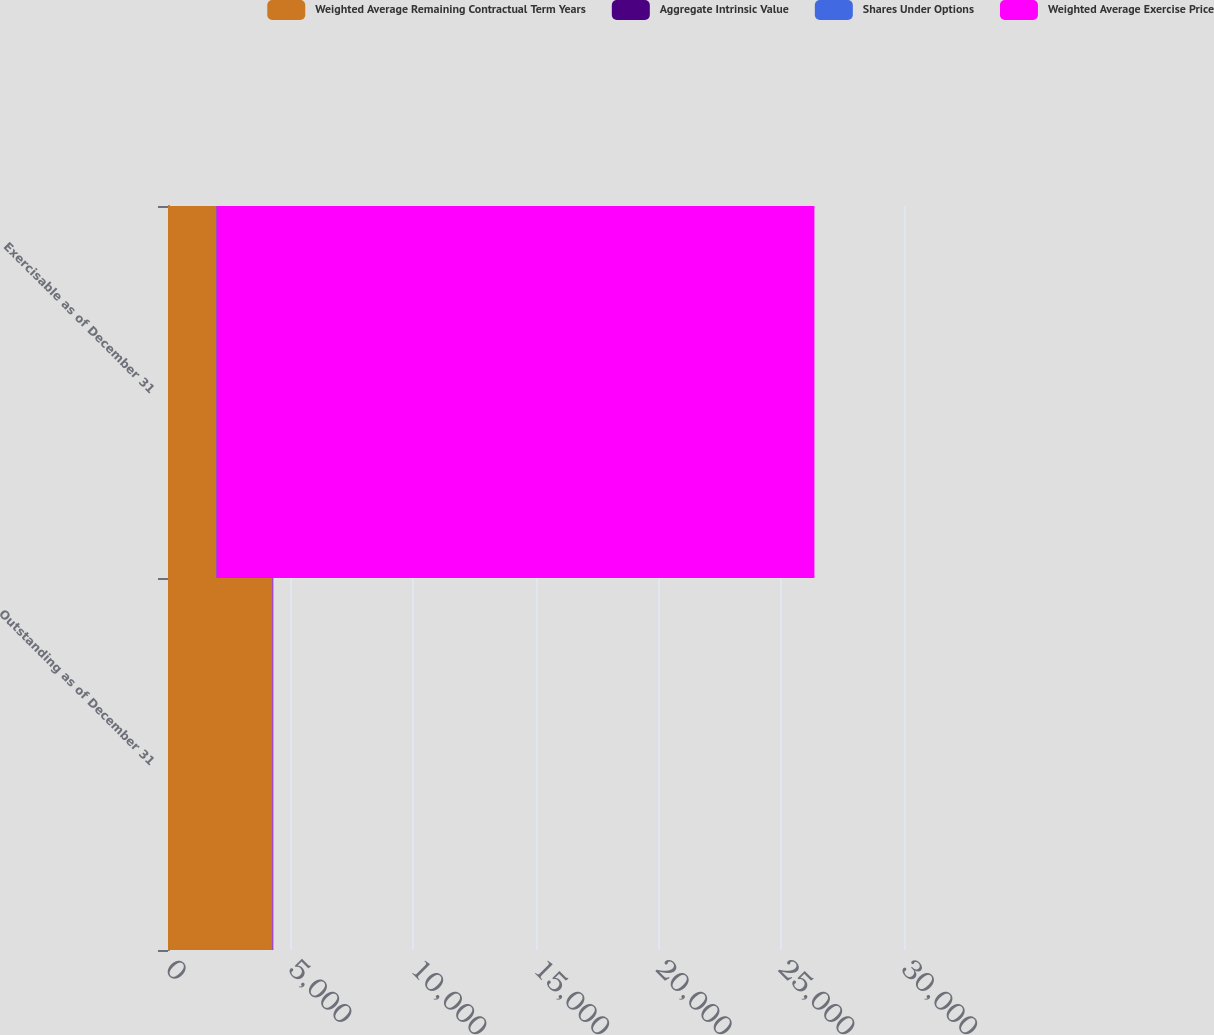Convert chart to OTSL. <chart><loc_0><loc_0><loc_500><loc_500><stacked_bar_chart><ecel><fcel>Outstanding as of December 31<fcel>Exercisable as of December 31<nl><fcel>Weighted Average Remaining Contractual Term Years<fcel>4236<fcel>1959<nl><fcel>Aggregate Intrinsic Value<fcel>26.25<fcel>22.47<nl><fcel>Shares Under Options<fcel>6.7<fcel>5.4<nl><fcel>Weighted Average Exercise Price<fcel>26.25<fcel>24362<nl></chart> 